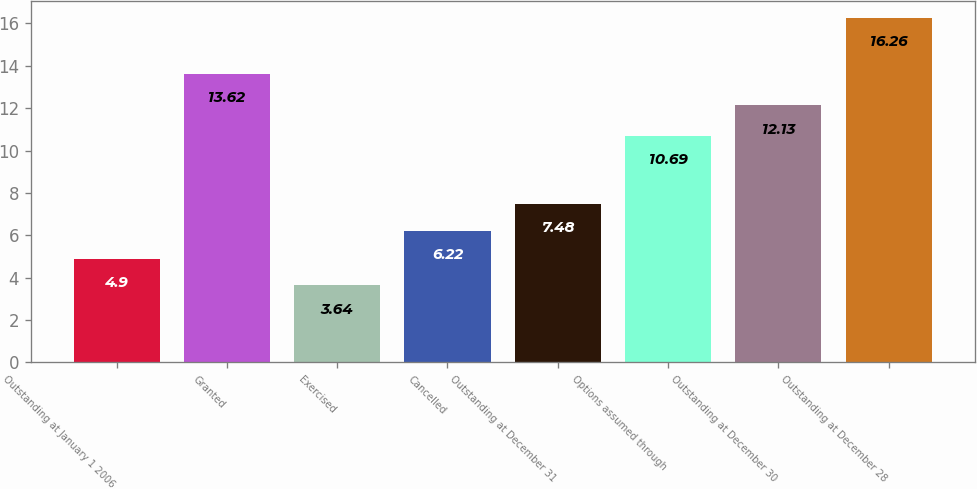Convert chart. <chart><loc_0><loc_0><loc_500><loc_500><bar_chart><fcel>Outstanding at January 1 2006<fcel>Granted<fcel>Exercised<fcel>Cancelled<fcel>Outstanding at December 31<fcel>Options assumed through<fcel>Outstanding at December 30<fcel>Outstanding at December 28<nl><fcel>4.9<fcel>13.62<fcel>3.64<fcel>6.22<fcel>7.48<fcel>10.69<fcel>12.13<fcel>16.26<nl></chart> 